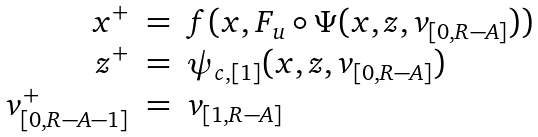<formula> <loc_0><loc_0><loc_500><loc_500>\begin{array} { r c l } x ^ { + } & = & f ( x , F _ { u } \circ \Psi ( x , z , v _ { [ 0 , R - A ] } ) ) \\ z ^ { + } & = & \psi _ { c , [ 1 ] } ( x , z , v _ { [ 0 , R - A ] } ) \\ v _ { [ 0 , R - A - 1 ] } ^ { + } & = & v _ { [ 1 , R - A ] } \end{array}</formula> 